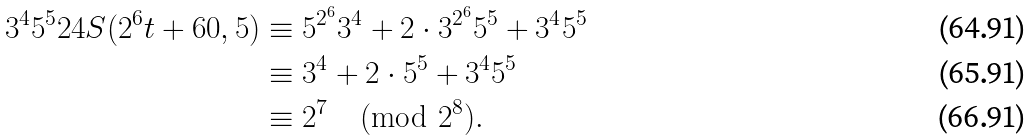Convert formula to latex. <formula><loc_0><loc_0><loc_500><loc_500>3 ^ { 4 } 5 ^ { 5 } 2 4 S ( 2 ^ { 6 } t + 6 0 , 5 ) & \equiv 5 ^ { 2 ^ { 6 } } 3 ^ { 4 } + 2 \cdot 3 ^ { 2 ^ { 6 } } 5 ^ { 5 } + 3 ^ { 4 } 5 ^ { 5 } \\ & \equiv 3 ^ { 4 } + 2 \cdot 5 ^ { 5 } + 3 ^ { 4 } 5 ^ { 5 } \\ & \equiv 2 ^ { 7 } \pmod { 2 ^ { 8 } } .</formula> 